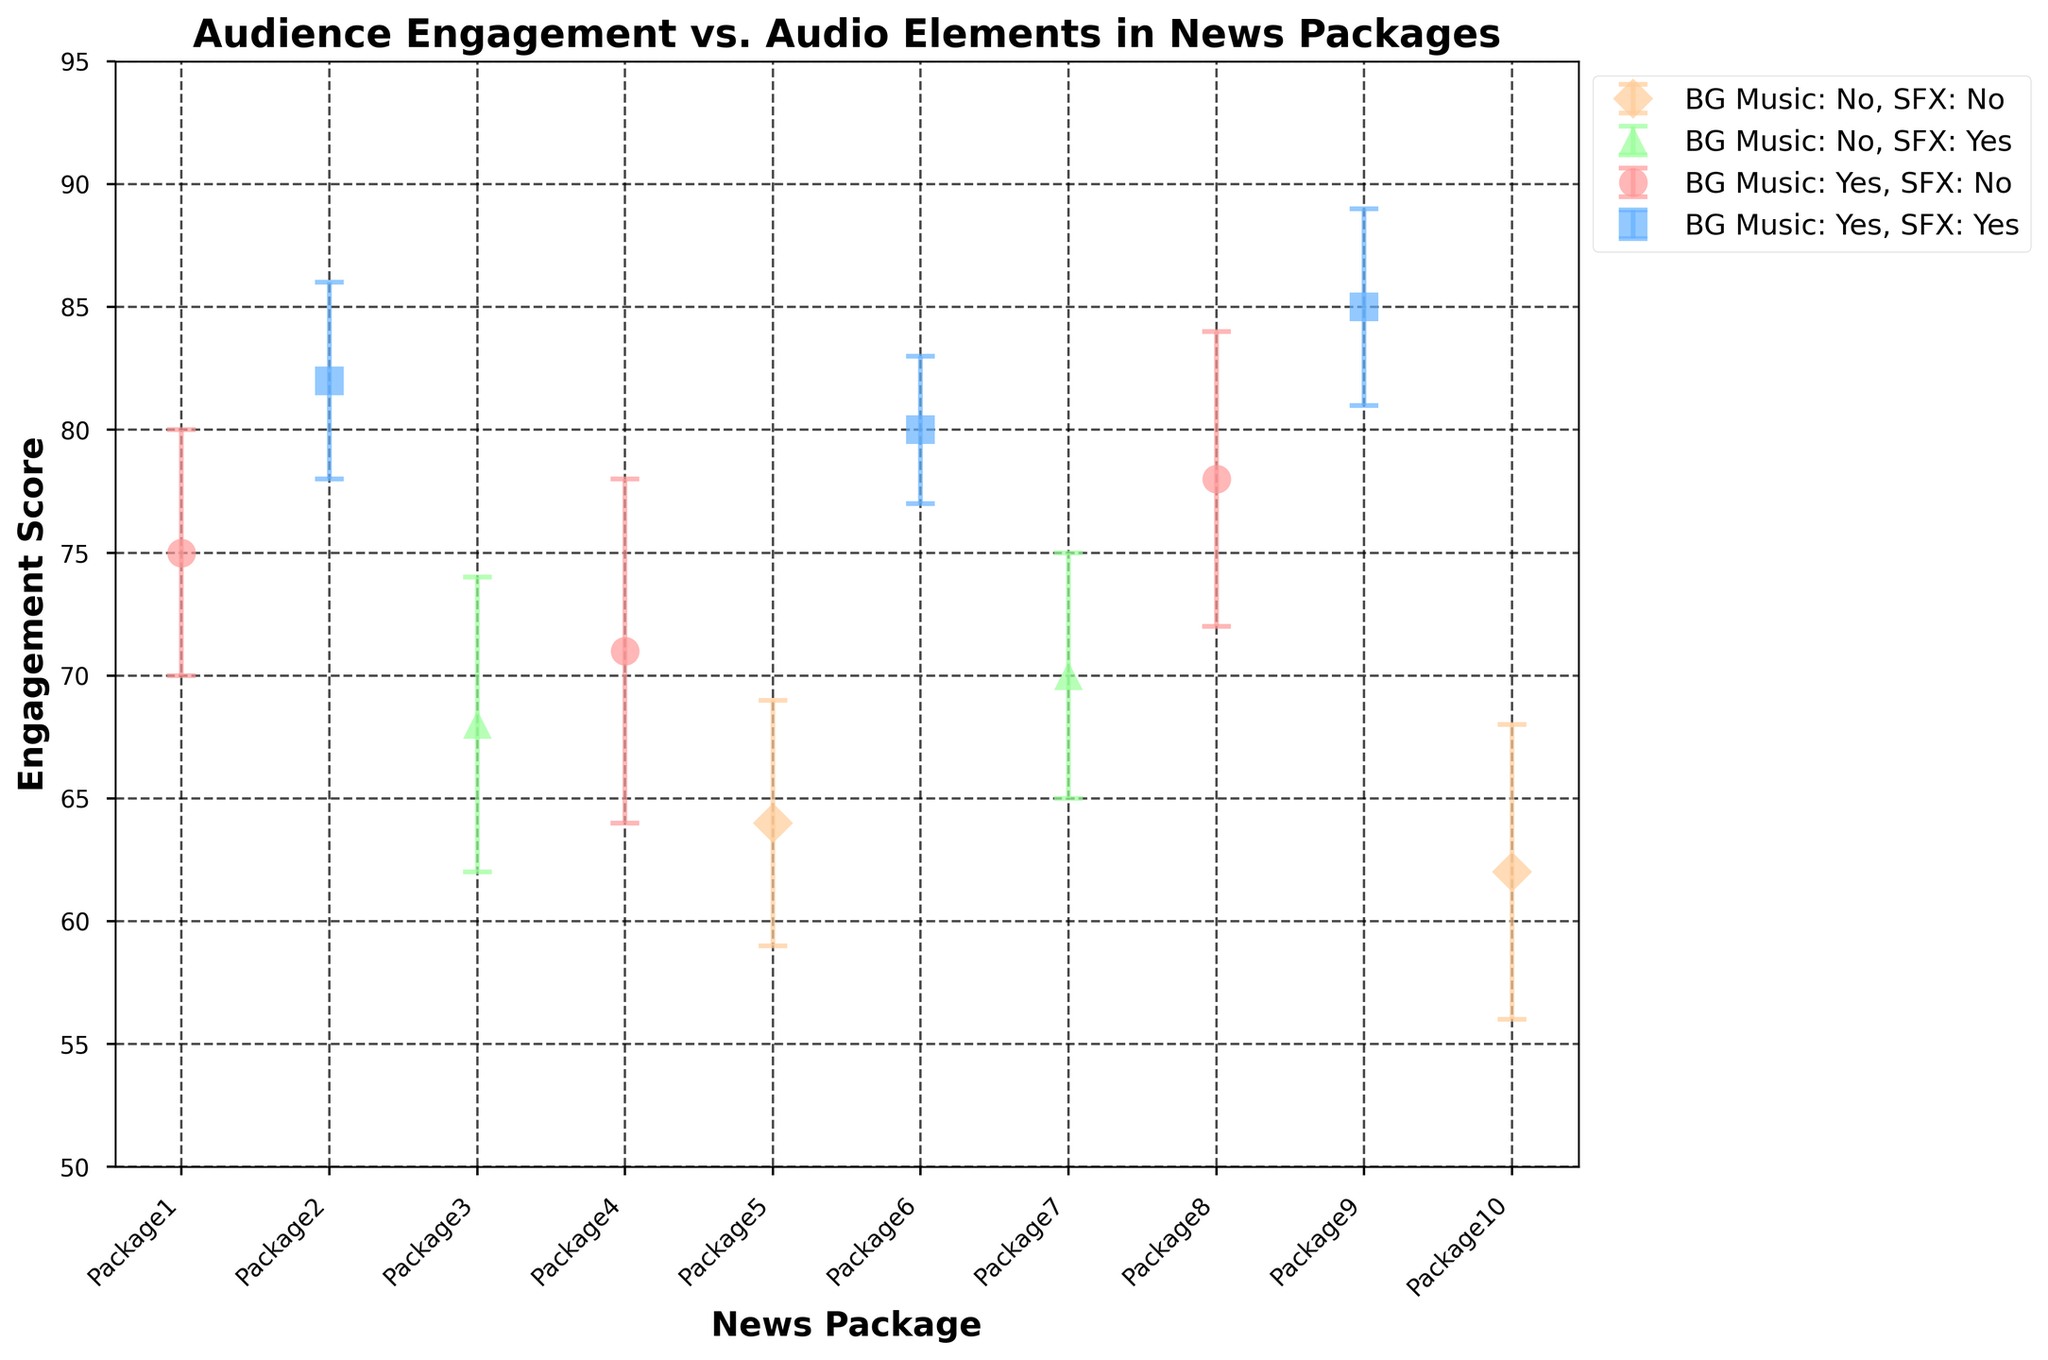How many news packages use both background music and sound effects? To identify the number of news packages that use both background music and sound effects, look for the label "BG Music: Yes, SFX: Yes" with the specific marker and color. Counting these markers from the legend, we see that three news packages use both.
Answer: 3 What is the title of the figure? The title of the figure is displayed at the top of the plot. It provides a summary of what the plot is about. In this case, the title of the figure is "Audience Engagement vs. Audio Elements in News Packages."
Answer: Audience Engagement vs. Audio Elements in News Packages Which audio element group has the lowest engagement score on average? To determine the lowest average engagement score, compare the engagement scores of each group by their labels "BG Music: Yes, SFX: Yes", "BG Music: Yes, SFX: No", "BG Music: No, SFX: Yes", and "BG Music: No, SFX: No". The scores can be summed and averaged for each group.
Answer: BG Music: No, SFX: No What range does the y-axis cover? The y-axis shows the range of the engagement scores. From the plot, we see that the y-axis ranges from 50 to 95.
Answer: 50 to 95 Which combination of audio elements achieves the highest individual engagement score and what is that score? To find the highest individual engagement score, identify the highest point on the plot. It corresponds to "BG Music: Yes, SFX: Yes" at an engagement score of 85.
Answer: BG Music: Yes, SFX: Yes, 85 What's the average engagement score of packages with only background music? Packages with only background music have the label "BG Music: Yes, SFX: No". Sum their scores: 75 (Package1) + 71 (Package4) + 78 (Package8) = 224. There are 3 such packages. So, the average is 224 / 3 = 74.7.
Answer: 74.7 What is the difference in average engagement scores between packages that have both audio elements and those without any? Calculate the average engagement scores for both groups. For "BG Music: Yes, SFX: Yes": (82 + 80 + 85) / 3 = 82.3. For "BG Music: No, SFX: No": (64 + 62) / 2 = 63.0. The difference is 82.3 - 63 = 19.3.
Answer: 19.3 What is the engagement score for Package3, and what are its engagement score error bars? Locate Package3 on the x-axis and note its engagement score and the error bars. For Package3, the engagement score is 68 with an error of ±6.
Answer: 68, ±6 